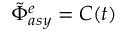Convert formula to latex. <formula><loc_0><loc_0><loc_500><loc_500>\tilde { \Phi } _ { a s y } ^ { e } = C ( t )</formula> 